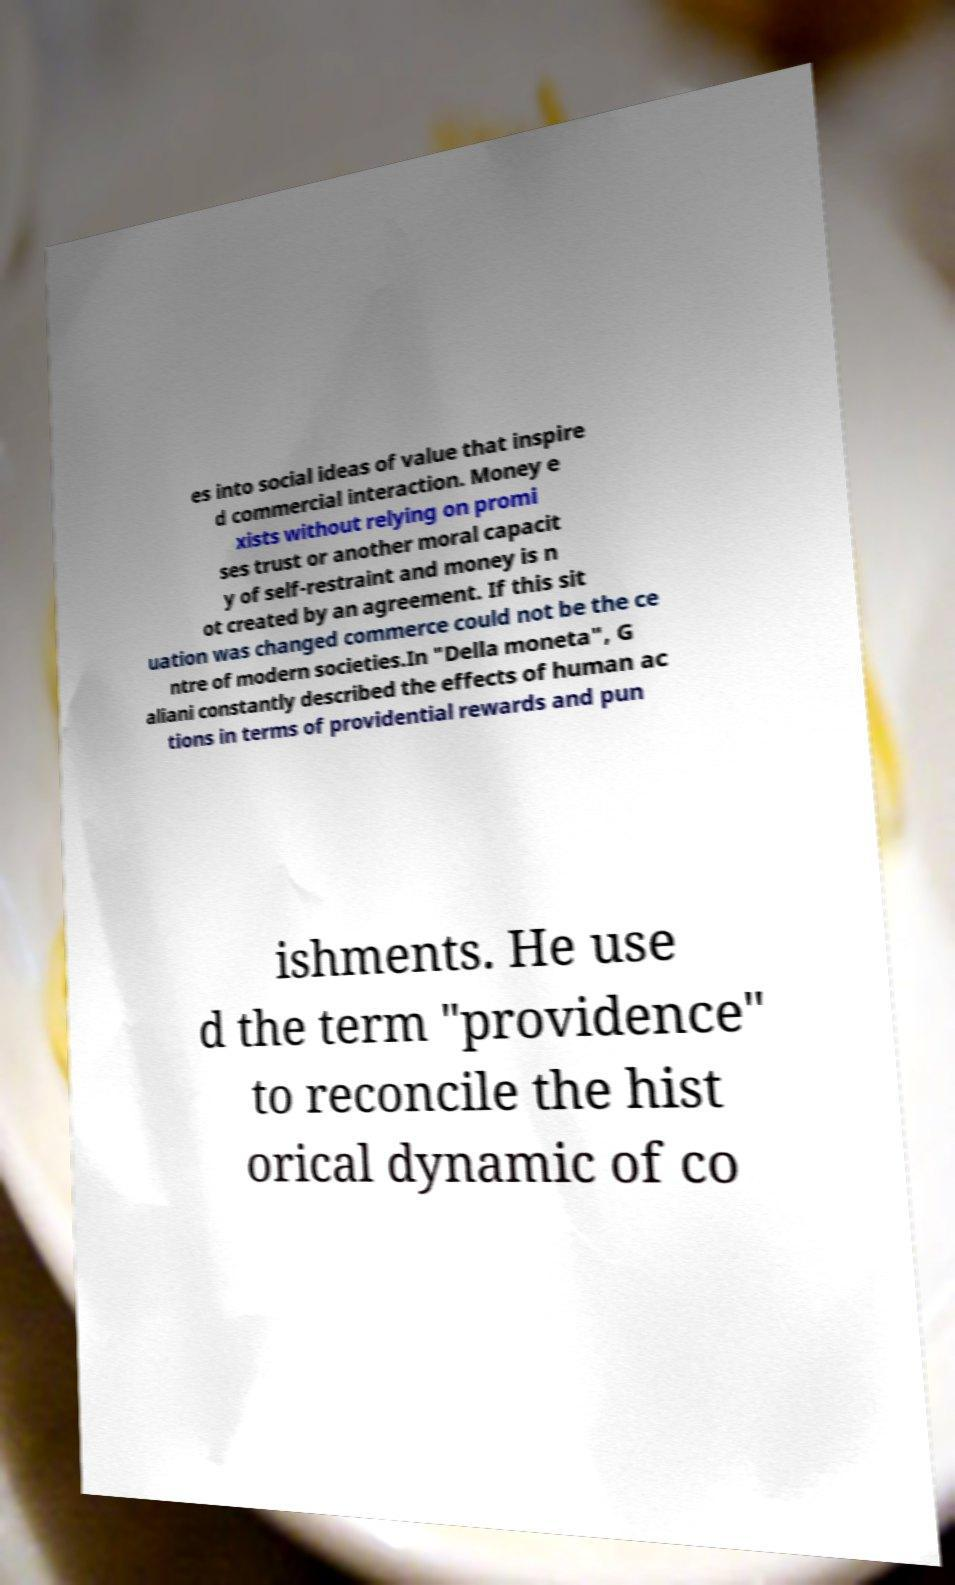Please read and relay the text visible in this image. What does it say? es into social ideas of value that inspire d commercial interaction. Money e xists without relying on promi ses trust or another moral capacit y of self-restraint and money is n ot created by an agreement. If this sit uation was changed commerce could not be the ce ntre of modern societies.In "Della moneta", G aliani constantly described the effects of human ac tions in terms of providential rewards and pun ishments. He use d the term "providence" to reconcile the hist orical dynamic of co 